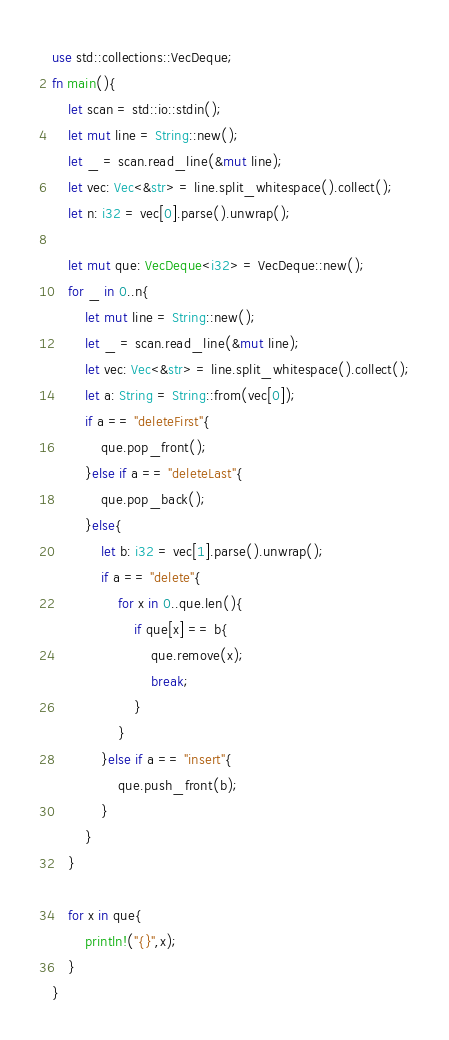Convert code to text. <code><loc_0><loc_0><loc_500><loc_500><_Rust_>use std::collections::VecDeque;
fn main(){
    let scan = std::io::stdin();
    let mut line = String::new();
    let _ = scan.read_line(&mut line);
    let vec: Vec<&str> = line.split_whitespace().collect();
    let n: i32 = vec[0].parse().unwrap();

    let mut que: VecDeque<i32> = VecDeque::new();
    for _ in 0..n{
        let mut line = String::new();
        let _ = scan.read_line(&mut line);
        let vec: Vec<&str> = line.split_whitespace().collect();
        let a: String = String::from(vec[0]);
        if a == "deleteFirst"{
            que.pop_front();
        }else if a == "deleteLast"{
            que.pop_back();
        }else{
            let b: i32 = vec[1].parse().unwrap();
            if a == "delete"{
                for x in 0..que.len(){
                    if que[x] == b{
                        que.remove(x);
                        break;
                    }
                }
            }else if a == "insert"{
                que.push_front(b);
            }
        }
    }

    for x in que{
        println!("{}",x);
    }
}</code> 